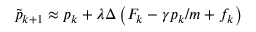Convert formula to latex. <formula><loc_0><loc_0><loc_500><loc_500>\tilde { p } _ { k + 1 } \approx p _ { k } + \lambda \Delta \left ( F _ { k } - \gamma p _ { k } / m + f _ { k } \right )</formula> 